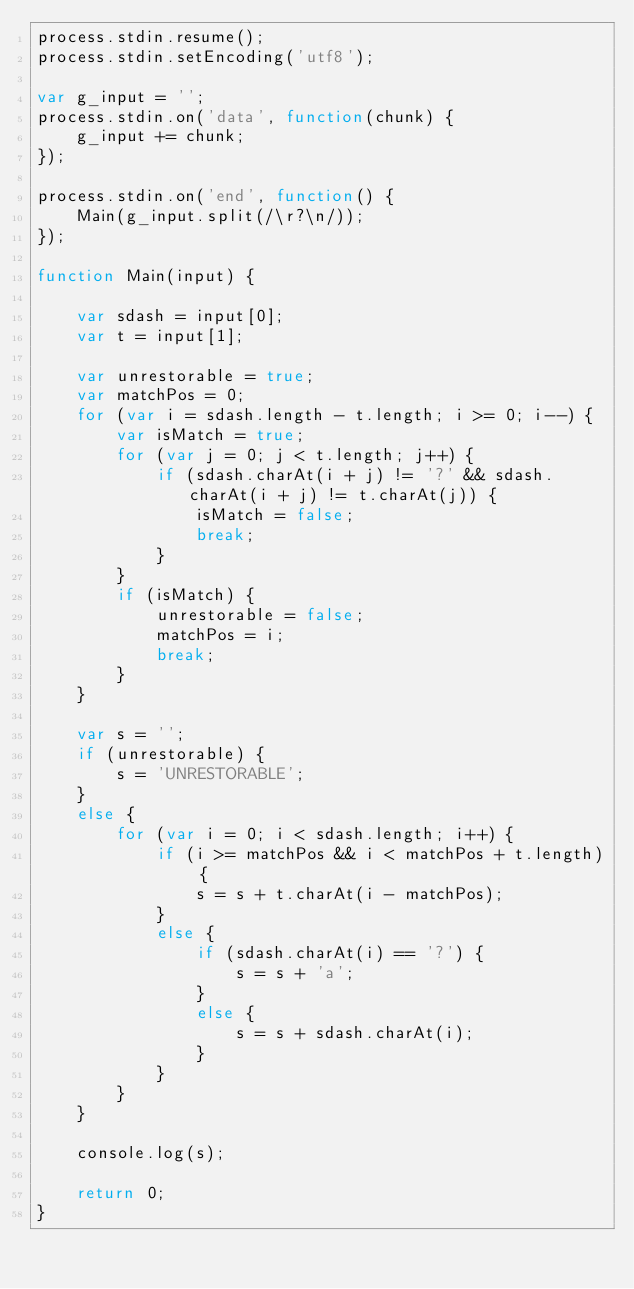<code> <loc_0><loc_0><loc_500><loc_500><_JavaScript_>process.stdin.resume();
process.stdin.setEncoding('utf8');

var g_input = '';
process.stdin.on('data', function(chunk) {
    g_input += chunk;
});

process.stdin.on('end', function() {
    Main(g_input.split(/\r?\n/));
});

function Main(input) {

    var sdash = input[0];
    var t = input[1];

    var unrestorable = true;
    var matchPos = 0;
    for (var i = sdash.length - t.length; i >= 0; i--) {
        var isMatch = true;
        for (var j = 0; j < t.length; j++) {
            if (sdash.charAt(i + j) != '?' && sdash.charAt(i + j) != t.charAt(j)) {
                isMatch = false;
                break;
            }
        }
        if (isMatch) {
            unrestorable = false;
            matchPos = i;
            break;
        }
    }

    var s = '';
    if (unrestorable) {
        s = 'UNRESTORABLE';
    }
    else {
        for (var i = 0; i < sdash.length; i++) {
            if (i >= matchPos && i < matchPos + t.length) {
                s = s + t.charAt(i - matchPos);
            }
            else {
                if (sdash.charAt(i) == '?') {
                    s = s + 'a';
                }
                else {
                    s = s + sdash.charAt(i);
                }
            }
        }
    }

    console.log(s);

    return 0;
}
</code> 